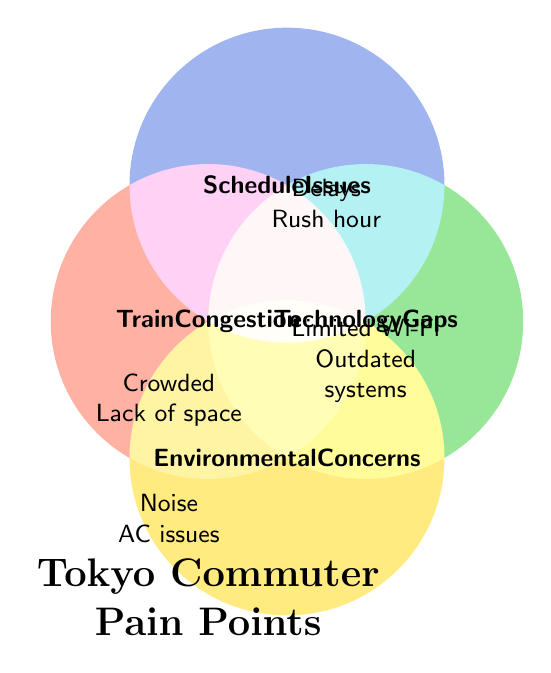What is the title of the figure? The title is typically placed prominently and provides a high-level summary of the diagram. Here, the title is located at the bottom of the diagram.
Answer: Tokyo Commuter Pain Points What color represents the "Technology Gaps" section? The colors are visually distinct and each major category has its own color. The section for "Technology Gaps" is colored in green.
Answer: Green Which pain points are associated with "Train Congestion"? The pain points are listed within the red circle labeled "Train Congestion". They include "Crowded trains", "Lack of personal space", and "Difficulty boarding".
Answer: Crowded trains, Lack of personal space, Difficulty boarding Is "Noise pollution" associated with "Environmental Concerns"? To figure this out, we look at the section labeled "Environmental Concerns" in the figure. "Noise pollution" is indeed one of the pain points listed under this category.
Answer: Yes Which categories include the pain point "Frequent delays"? Identify where "Frequent delays" is listed which is within the blue circle labeled "Schedule Issues".
Answer: Schedule Issues How many pain points are related to "Schedule Issues"? Count the number of pain points listed under the "Schedule Issues" section. There are three: "Frequent delays", "Confusing timetables", and "Rush hour bottlenecks".
Answer: 3 Are there more pain points related to "Train Congestion" or "Environmental Concerns"? Compare the number of pain points listed in each section. "Train Congestion" has three, whereas "Environmental Concerns" also has three.
Answer: Equal What is the relationship between "Technology Gaps" and "Environmental Concerns" in terms of shared pain points? Examine the Venn diagram to see if there is any overlap between "Technology Gaps" and "Environmental Concerns". There are no pain points listed in an overlapping region between these two categories.
Answer: No overlap Which category does not have an overlap with others? This can be determined by looking for sections in the Venn diagram that have exclusive areas without any shared regions with other categories. "Environmental Concerns" is such a category.
Answer: Environmental Concerns 